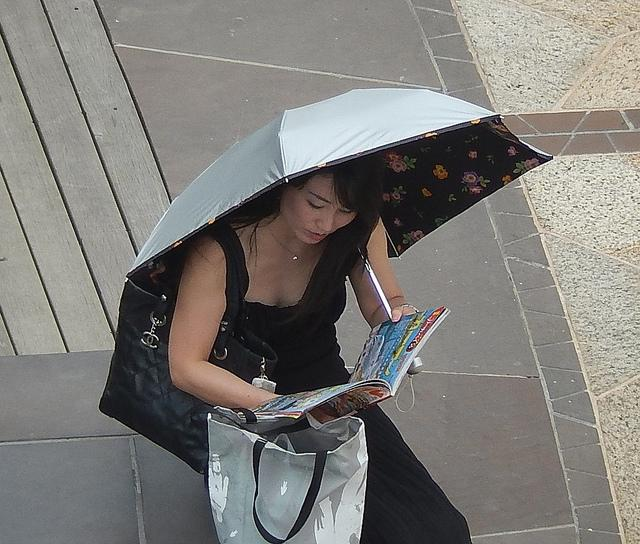What does the lady use the umbrella for? Please explain your reasoning. shade. The woman wants to keep the sun out. 